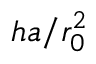Convert formula to latex. <formula><loc_0><loc_0><loc_500><loc_500>h a / r _ { 0 } ^ { 2 }</formula> 